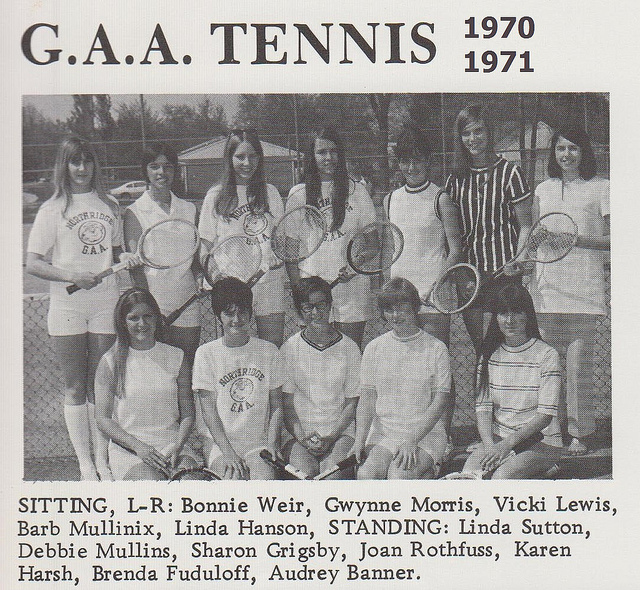Please transcribe the text in this image. G A A TENNIS 1970 1971 